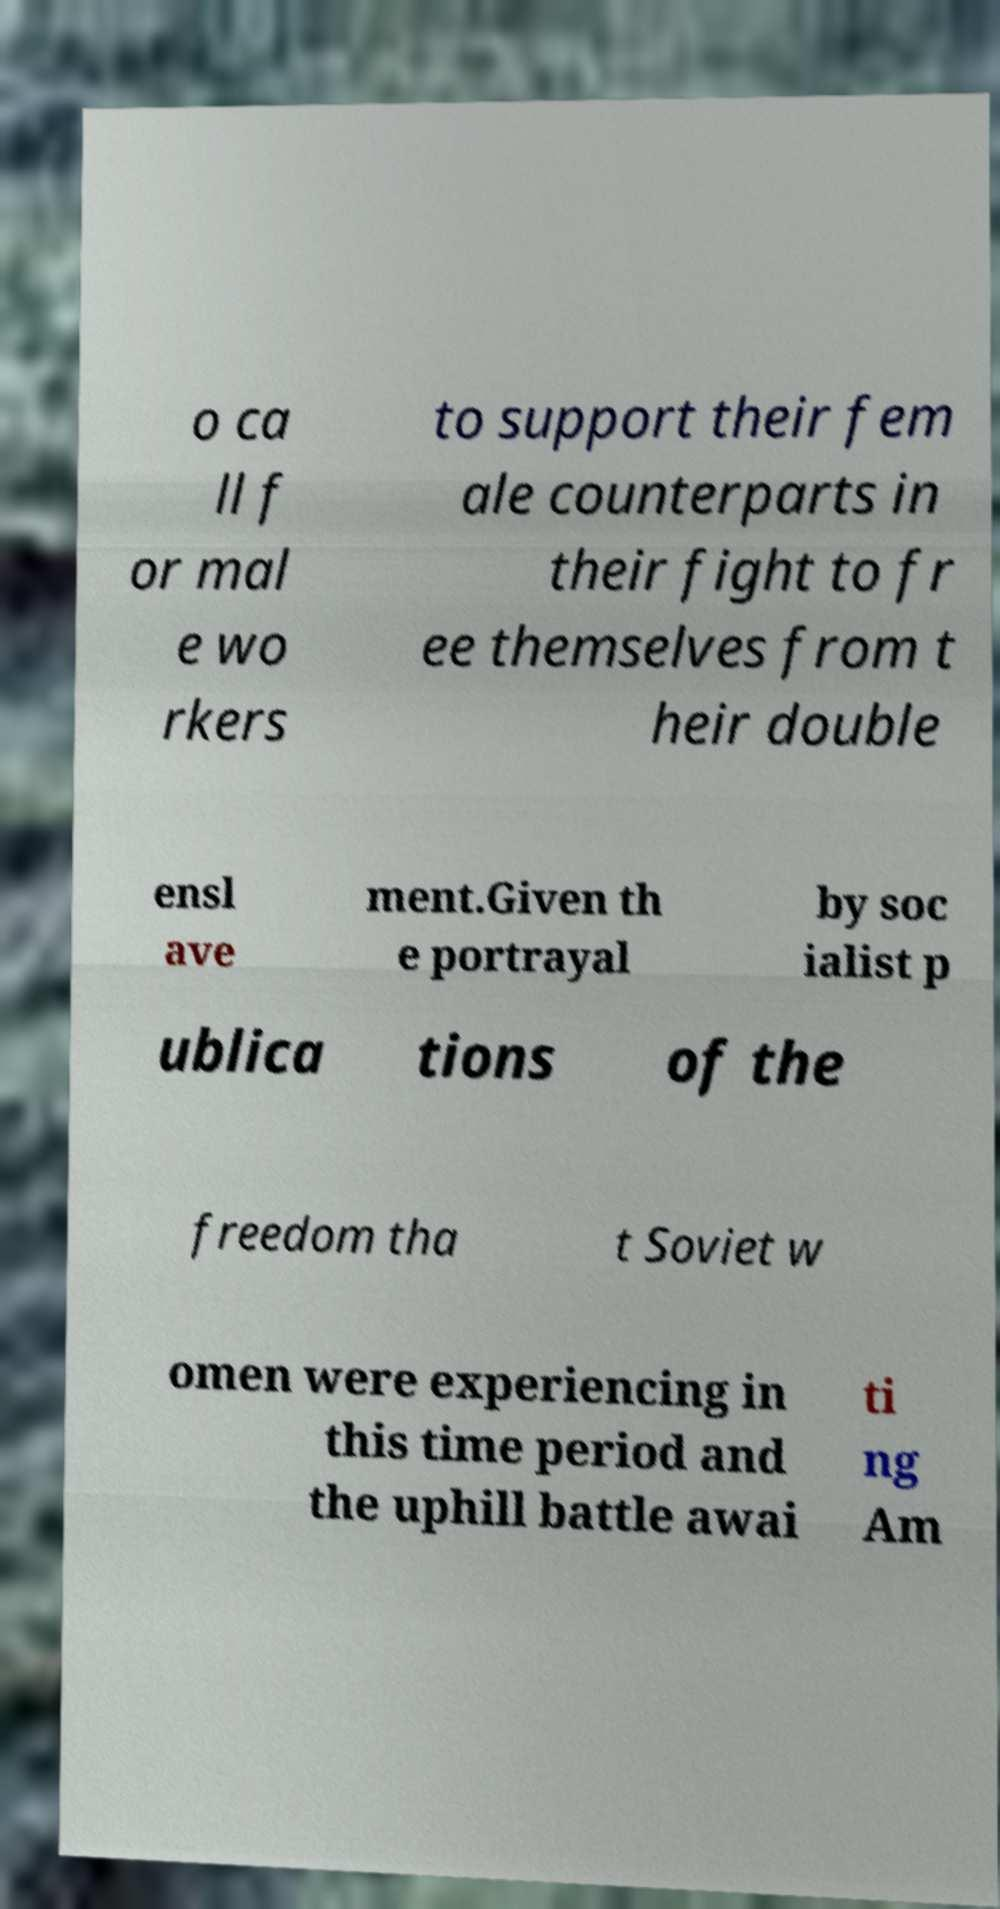I need the written content from this picture converted into text. Can you do that? o ca ll f or mal e wo rkers to support their fem ale counterparts in their fight to fr ee themselves from t heir double ensl ave ment.Given th e portrayal by soc ialist p ublica tions of the freedom tha t Soviet w omen were experiencing in this time period and the uphill battle awai ti ng Am 